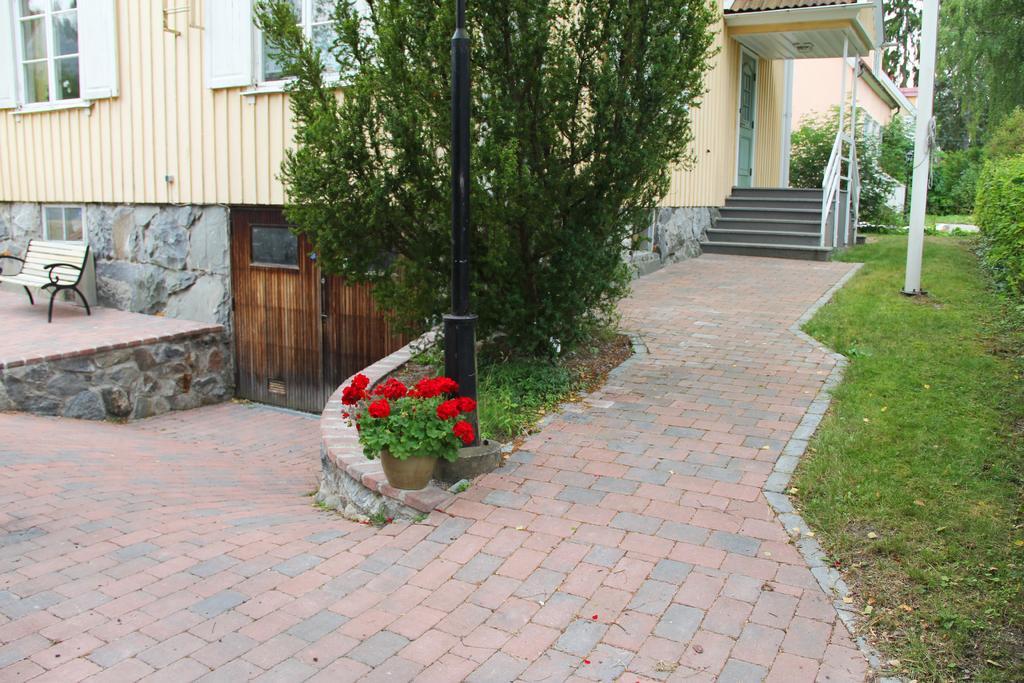Describe this image in one or two sentences. In this image we can see one building, one staircase, one plant with red flowers in the pot, two doors, one bench, one curtain in the window, one object in the window, some objects attached to the building, one black pole, one wire attached to the white pole, three objects looks like rocks on the ground, some dried leaves, some trees, some plants and grass on the ground. 